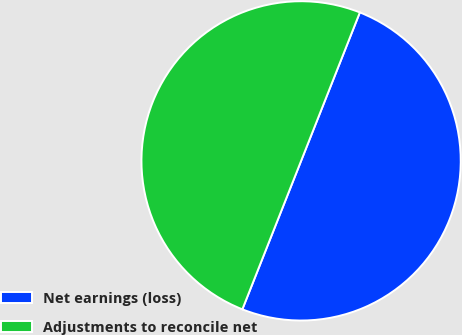Convert chart. <chart><loc_0><loc_0><loc_500><loc_500><pie_chart><fcel>Net earnings (loss)<fcel>Adjustments to reconcile net<nl><fcel>50.0%<fcel>50.0%<nl></chart> 